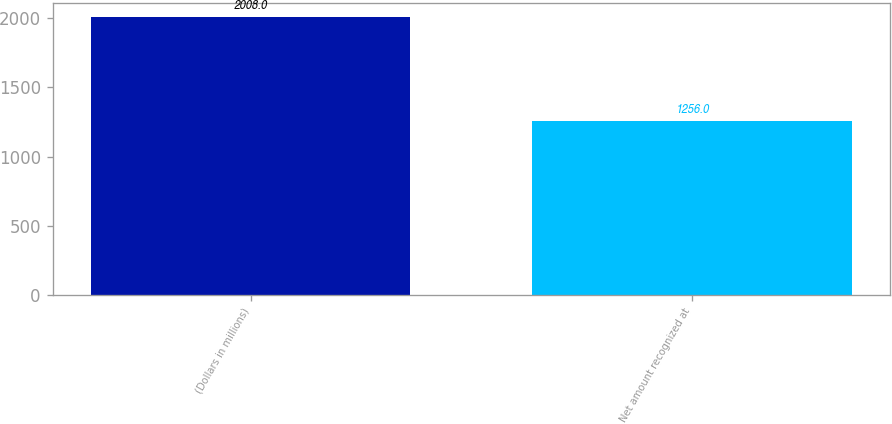Convert chart to OTSL. <chart><loc_0><loc_0><loc_500><loc_500><bar_chart><fcel>(Dollars in millions)<fcel>Net amount recognized at<nl><fcel>2008<fcel>1256<nl></chart> 